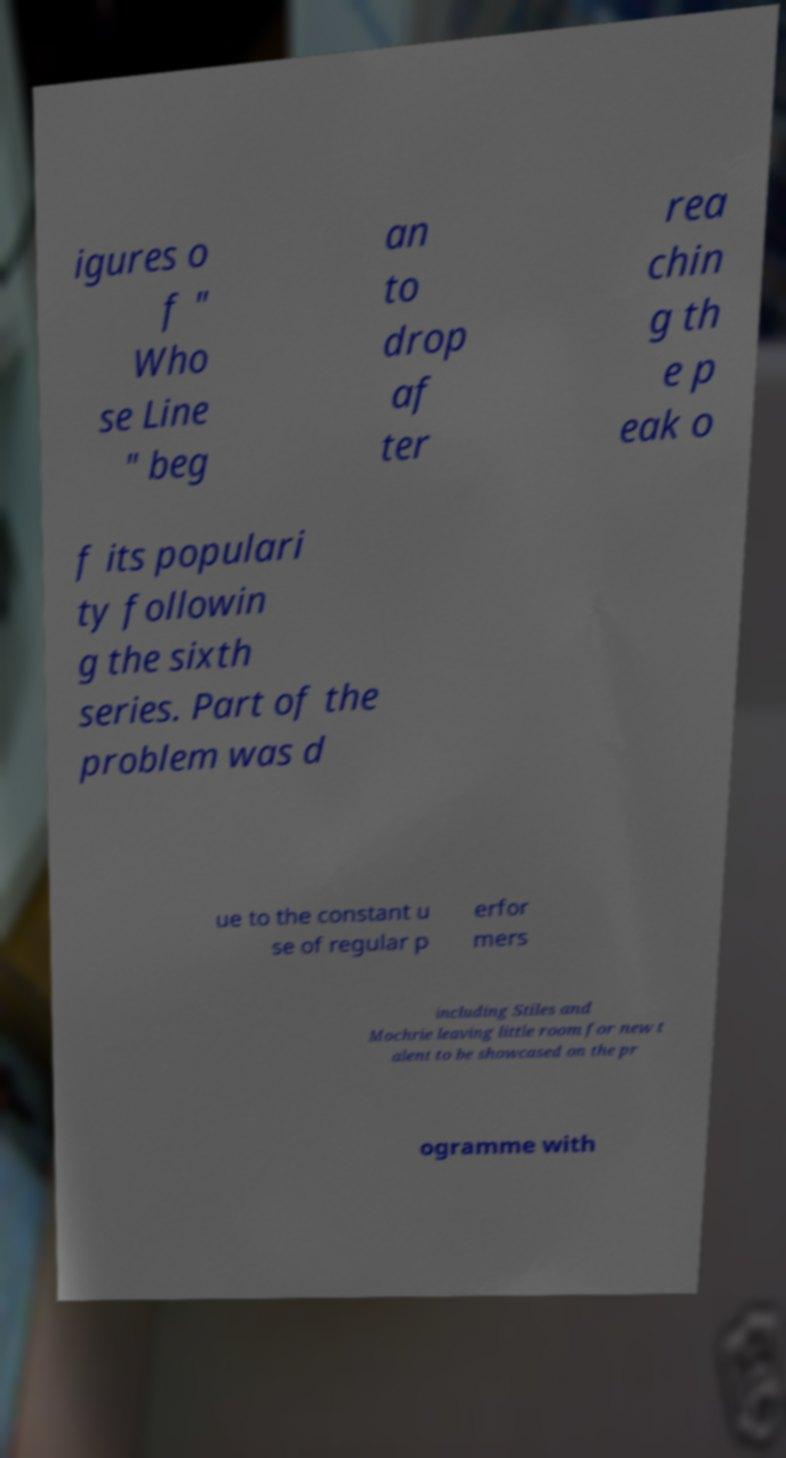Can you read and provide the text displayed in the image?This photo seems to have some interesting text. Can you extract and type it out for me? igures o f " Who se Line " beg an to drop af ter rea chin g th e p eak o f its populari ty followin g the sixth series. Part of the problem was d ue to the constant u se of regular p erfor mers including Stiles and Mochrie leaving little room for new t alent to be showcased on the pr ogramme with 